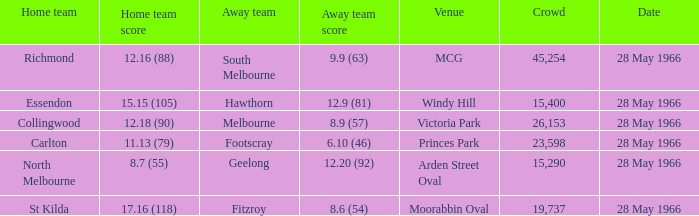Where can a crowd be found with an away team scoring 8.6 (54)? 19737.0. 